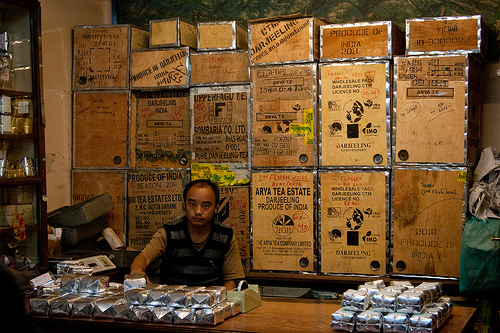<image>
Is there a box behind the man? Yes. From this viewpoint, the box is positioned behind the man, with the man partially or fully occluding the box. 